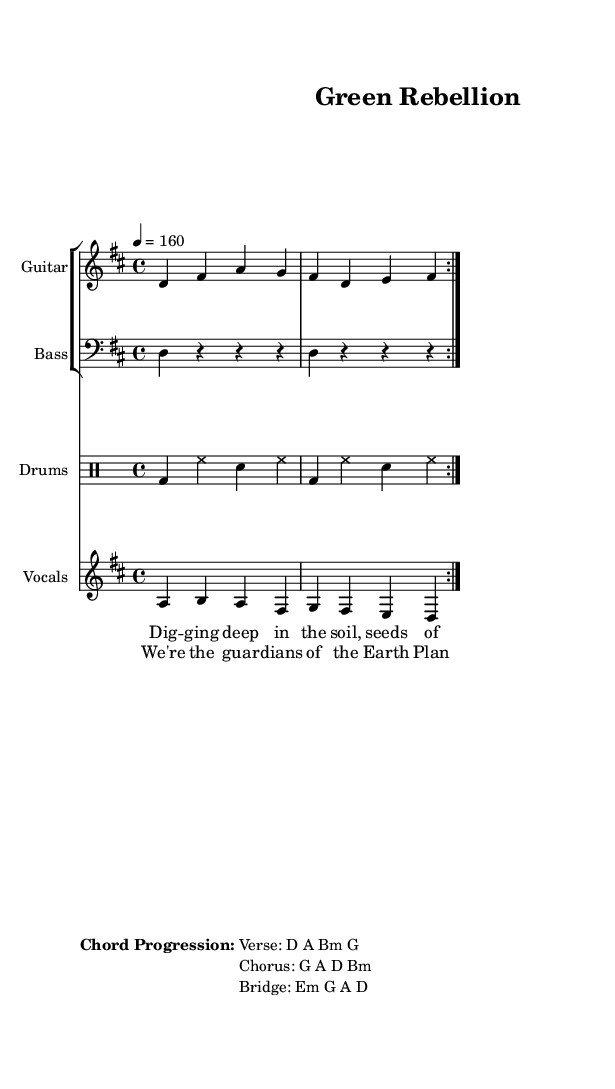What is the key signature of this music? The key signature is D major, which has two sharps (F sharp and C sharp). This can be determined by examining the key indicated at the beginning of the score.
Answer: D major What is the time signature of this music? The time signature is 4/4, which is identified in the `\time` directive in the global section of the code. This means there are four beats in each measure, and each beat is a quarter note long.
Answer: 4/4 What is the tempo of the piece? The tempo is 160 beats per minute, as indicated by the `\tempo` directive in the global section of the code. It specifies the speed at which the music should be played.
Answer: 160 What is the chord progression for the verse? The chord progression for the verse is D A Bm G, which is listed under the "Chord Progression:" markup at the end of the score. This indicates the chords that should accompany the lyrics of the verse.
Answer: D A Bm G How many times do the guitar and drums repeat the section? The guitar and drums repeat the section 2 times, which is indicated by the `\repeat volta 2` command within the music notation sections for both instruments. This notation signifies that these measures are to be played twice.
Answer: 2 What is the thematic focus of the lyrics? The lyrics focus on gardening and environmental preservation, as indicated by phrases like "Digging deep in the soil" and "guardians of the Earth," showing a strong connection to nature. This theme aligns with the overall concept of the punk genre promoting activism and awareness.
Answer: Gardening and environmental preservation 